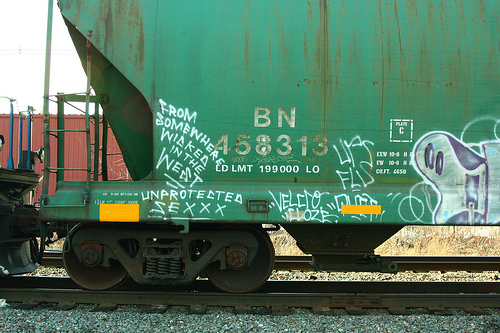<image>
Is the cargo train behind the railroad tracks? No. The cargo train is not behind the railroad tracks. From this viewpoint, the cargo train appears to be positioned elsewhere in the scene. 